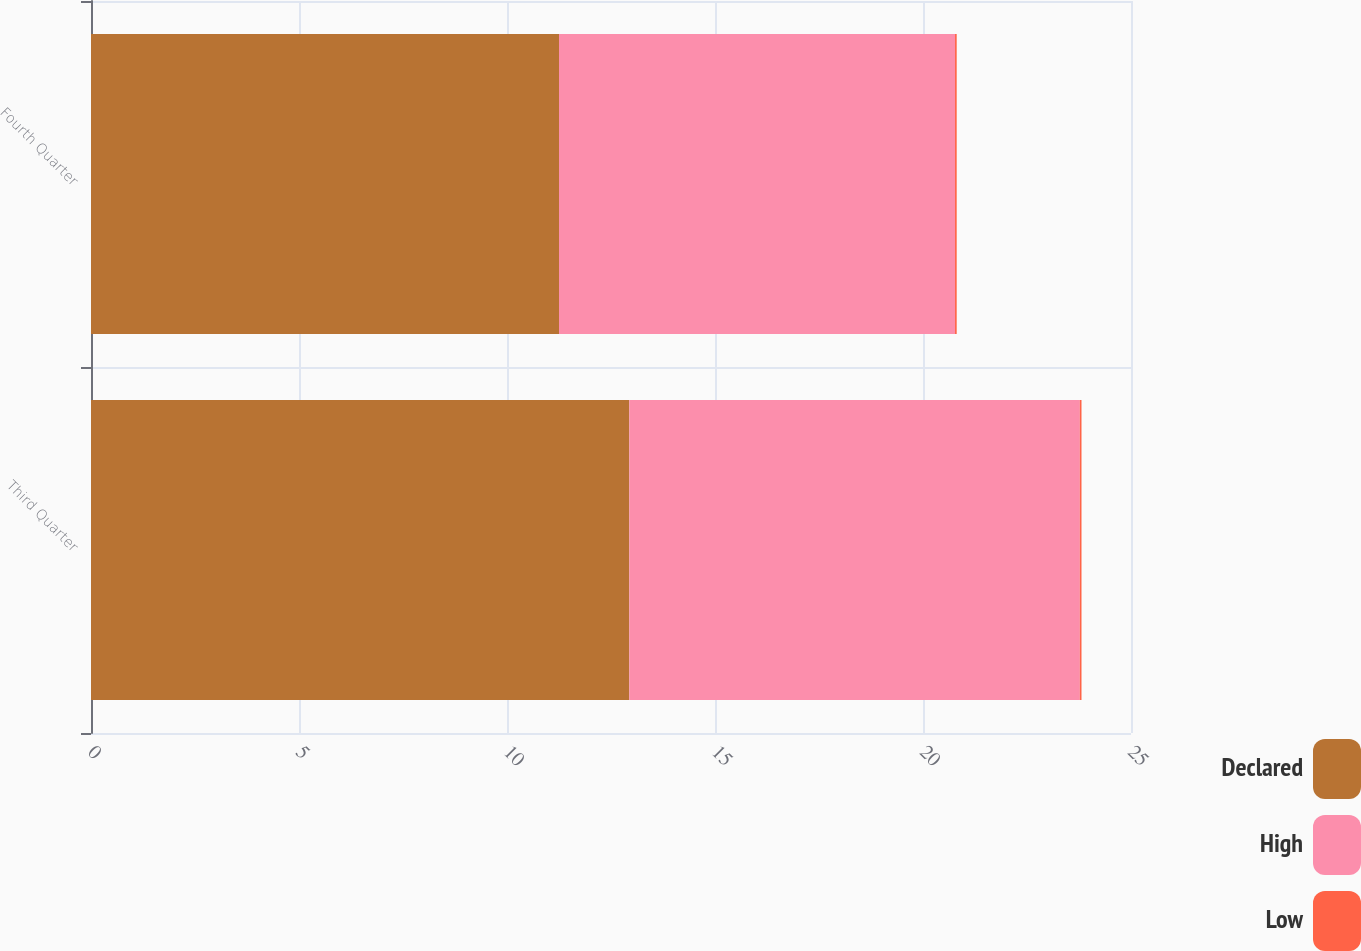Convert chart to OTSL. <chart><loc_0><loc_0><loc_500><loc_500><stacked_bar_chart><ecel><fcel>Third Quarter<fcel>Fourth Quarter<nl><fcel>Declared<fcel>12.94<fcel>11.25<nl><fcel>High<fcel>10.83<fcel>9.52<nl><fcel>Low<fcel>0.04<fcel>0.04<nl></chart> 